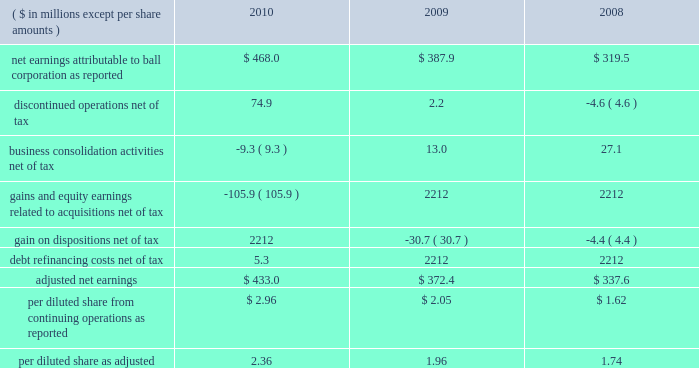Page 26 of 100 our calculation of adjusted net earnings is summarized below: .
Debt facilities and refinancing interest-bearing debt at december 31 , 2010 , increased $ 216.1 million to $ 2.8 billion from $ 2.6 billion at december 31 , 2009 .
In december 2010 , ball replaced its senior credit facilities due october 2011 with new senior credit facilities due december 2015 .
The senior credit facilities bear interest at variable rates and include a $ 200 million term a loan denominated in u.s .
Dollars , a a351 million term b loan denominated in british sterling and a 20ac100 million term c loan denominated in euros .
The facilities also include ( 1 ) a multi-currency , long-term revolving credit facility that provides the company with up to approximately $ 850 million and ( 2 ) a french multi-currency revolving facility that provides the company with up to $ 150 million .
The revolving credit facilities expire in december 2015 .
In november 2010 , ball issued $ 500 million of new 5.75 percent senior notes due in may 2021 .
The net proceeds from this offering were used to repay the borrowings under our term d loan facility and for general corporate purposes .
In march 2010 , ball issued $ 500 million of new 6.75 percent senior notes due in september 2020 .
On that same date , the company issued a notice of redemption to call $ 509 million in 6.875 percent senior notes due december 2012 at a redemption price of 101.146 percent of the outstanding principal amount plus accrued interest .
The redemption of the bonds occurred on april 21 , 2010 , and resulted in a charge of $ 8.1 million for the call premium and the write off of unamortized financing costs and unamortized premiums .
The charge is included in the 2010 statement of earnings as a component of interest expense .
At december 31 , 2010 , approximately $ 976 million was available under the company 2019s committed multi-currency revolving credit facilities .
The company 2019s prc operations also had approximately $ 20 million available under a committed credit facility of approximately $ 52 million .
In addition to the long-term committed credit facilities , the company had $ 372 million of short-term uncommitted credit facilities available at the end of 2010 , of which $ 76.2 million was outstanding and due on demand , as well as approximately $ 175 million of available borrowings under its accounts receivable securitization program .
In october 2010 , the company renewed its receivables sales agreement for a period of one year .
The size of the new program will vary between a maximum of $ 125 million for settlement dates in january through april and a maximum of $ 175 million for settlement dates in the remaining months .
Given our free cash flow projections and unused credit facilities that are available until december 2015 , our liquidity is strong and is expected to meet our ongoing operating cash flow and debt service requirements .
While the recent financial and economic conditions have raised concerns about credit risk with counterparties to derivative transactions , the company mitigates its exposure by spreading the risk among various counterparties and limiting exposure to any one party .
We also monitor the credit ratings of our suppliers , customers , lenders and counterparties on a regular basis .
We were in compliance with all loan agreements at december 31 , 2010 , and all prior years presented , and have met all debt payment obligations .
The u.s .
Note agreements , bank credit agreement and industrial development revenue bond agreements contain certain restrictions relating to dividends , investments , financial ratios , guarantees and the incurrence of additional indebtedness .
Additional details about our debt and receivables sales agreements are available in notes 12 and 6 , respectively , accompanying the consolidated financial statements within item 8 of this report. .
For the receivables sales agreement , what is the increase in the size of the new program in the last 8 months of the year compared to the first 4 months ( in millions ) ? 
Computations: (175 - 125)
Answer: 50.0. 